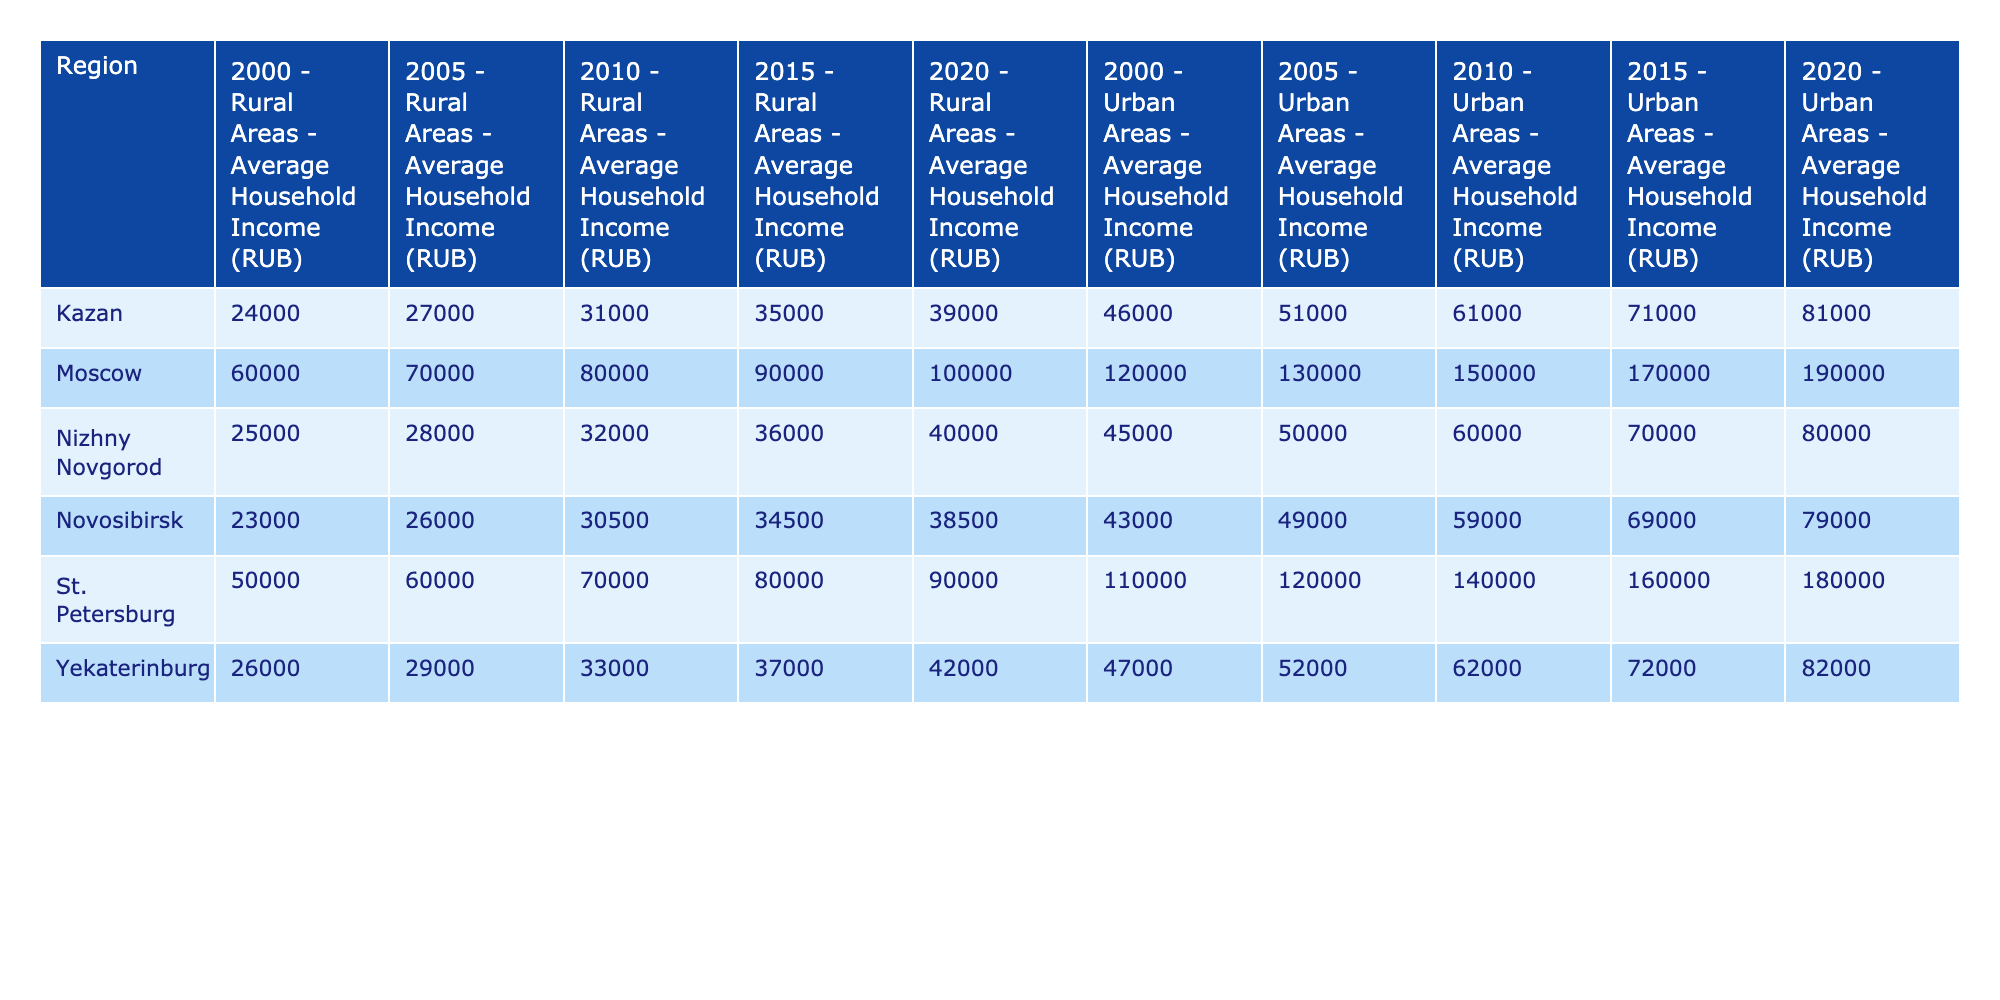What was the average household income in rural areas of Moscow in 2010? In 2010, the table indicates that the average household income in rural areas of Moscow was 80,000 RUB.
Answer: 80,000 RUB Which region had the highest urban household income in 2020? Referring to the data for 2020, Moscow had the highest urban household income at 190,000 RUB.
Answer: Moscow What is the difference in average household income between rural and urban areas in Nizhny Novgorod in 2015? In Nizhny Novgorod, the average rural household income in 2015 was 36,000 RUB, while the urban income was 70,000 RUB. The difference is 70,000 - 36,000 = 34,000 RUB.
Answer: 34,000 RUB Has the average rural household income in Kazan increased from 2000 to 2020? In 2000, the rural household income in Kazan was 24,000 RUB, and in 2020 it increased to 39,000 RUB. Therefore, the income has indeed increased over this period.
Answer: Yes What was the percentage increase in average rural household income in Novosibirsk from 2000 to 2020? In Novosibirsk, the rural household income was 23,000 RUB in 2000 and 38,500 RUB in 2020. To find the percentage increase: ((38,500 - 23,000) / 23,000) * 100 = 67.39%.
Answer: 67.39% 